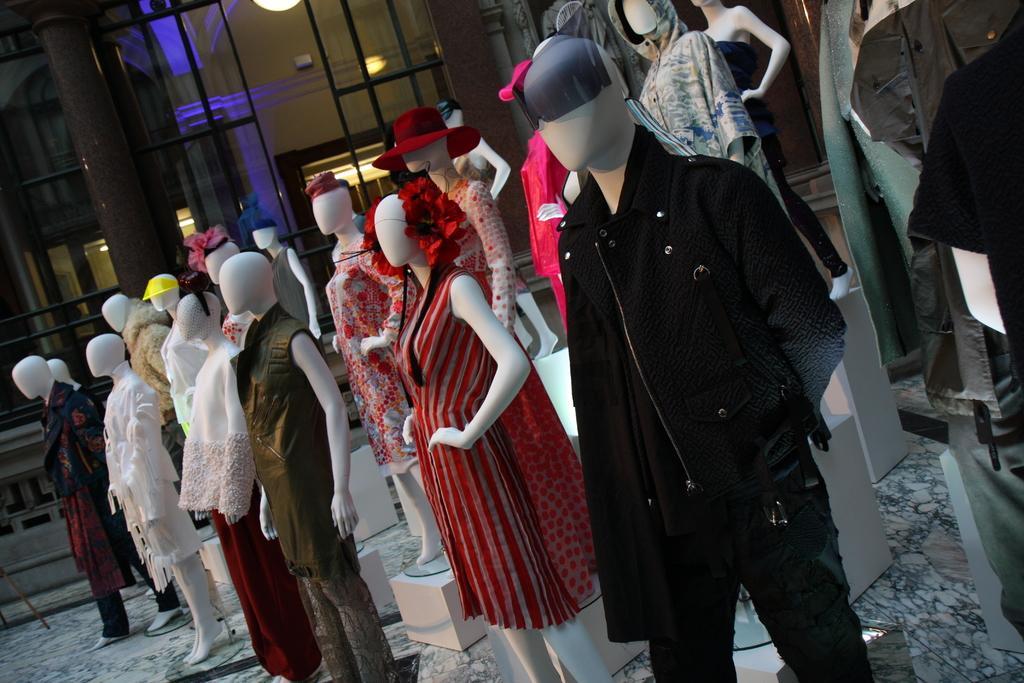Describe this image in one or two sentences. Here we can see both men and women dolls and wore dresses respectively. In the background there is a building,glass doors,lights and poles. 